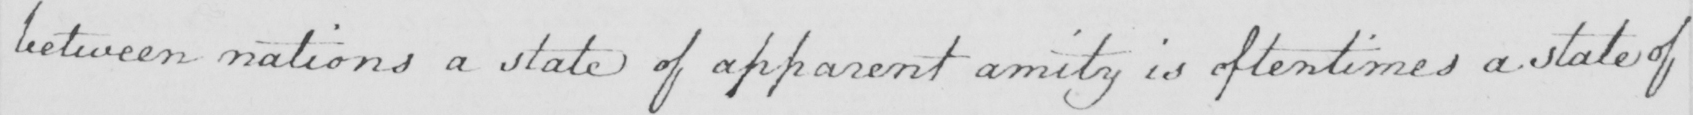What text is written in this handwritten line? between nations a state of apparent amity is oftentimes a state of 